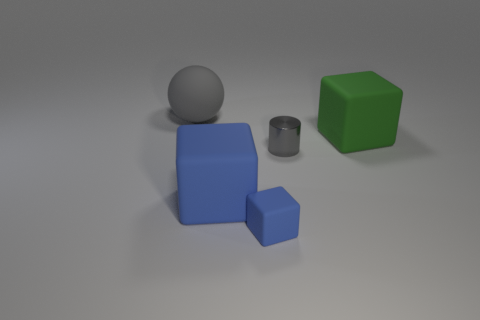Add 3 balls. How many objects exist? 8 Subtract all blocks. How many objects are left? 2 Subtract all gray things. Subtract all rubber cubes. How many objects are left? 0 Add 4 large green blocks. How many large green blocks are left? 5 Add 2 large metallic cylinders. How many large metallic cylinders exist? 2 Subtract 0 blue spheres. How many objects are left? 5 